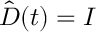<formula> <loc_0><loc_0><loc_500><loc_500>\hat { D } ( t ) = I</formula> 